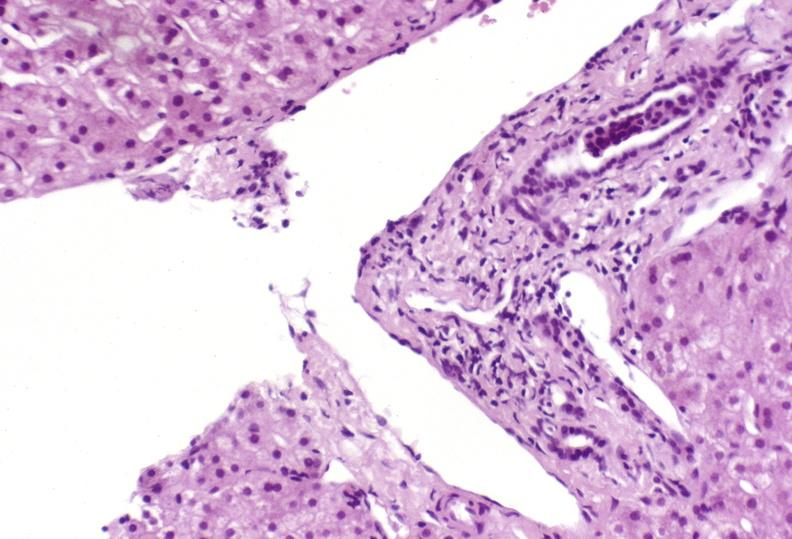does liver show mild acute rejection?
Answer the question using a single word or phrase. No 